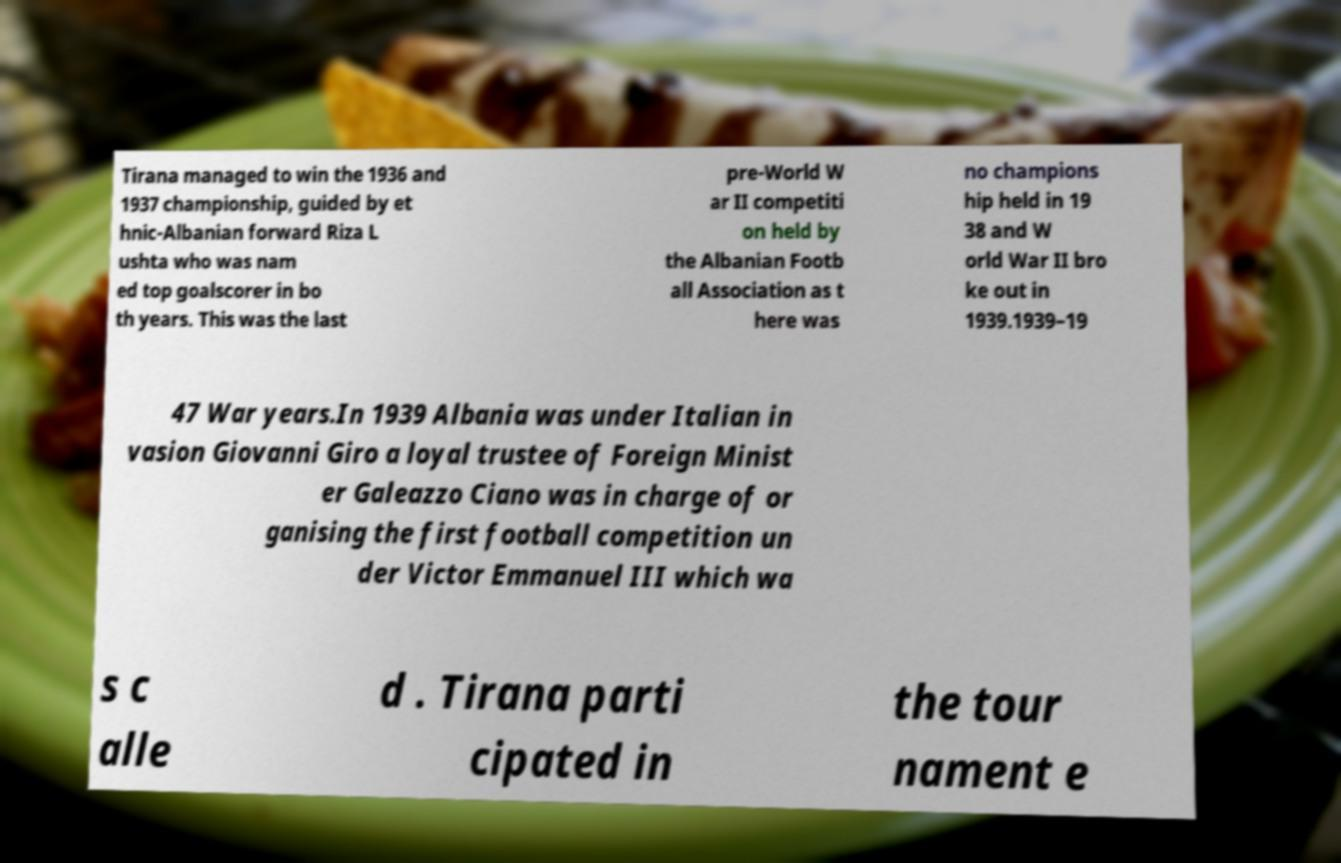Please read and relay the text visible in this image. What does it say? Tirana managed to win the 1936 and 1937 championship, guided by et hnic-Albanian forward Riza L ushta who was nam ed top goalscorer in bo th years. This was the last pre-World W ar II competiti on held by the Albanian Footb all Association as t here was no champions hip held in 19 38 and W orld War II bro ke out in 1939.1939–19 47 War years.In 1939 Albania was under Italian in vasion Giovanni Giro a loyal trustee of Foreign Minist er Galeazzo Ciano was in charge of or ganising the first football competition un der Victor Emmanuel III which wa s c alle d . Tirana parti cipated in the tour nament e 